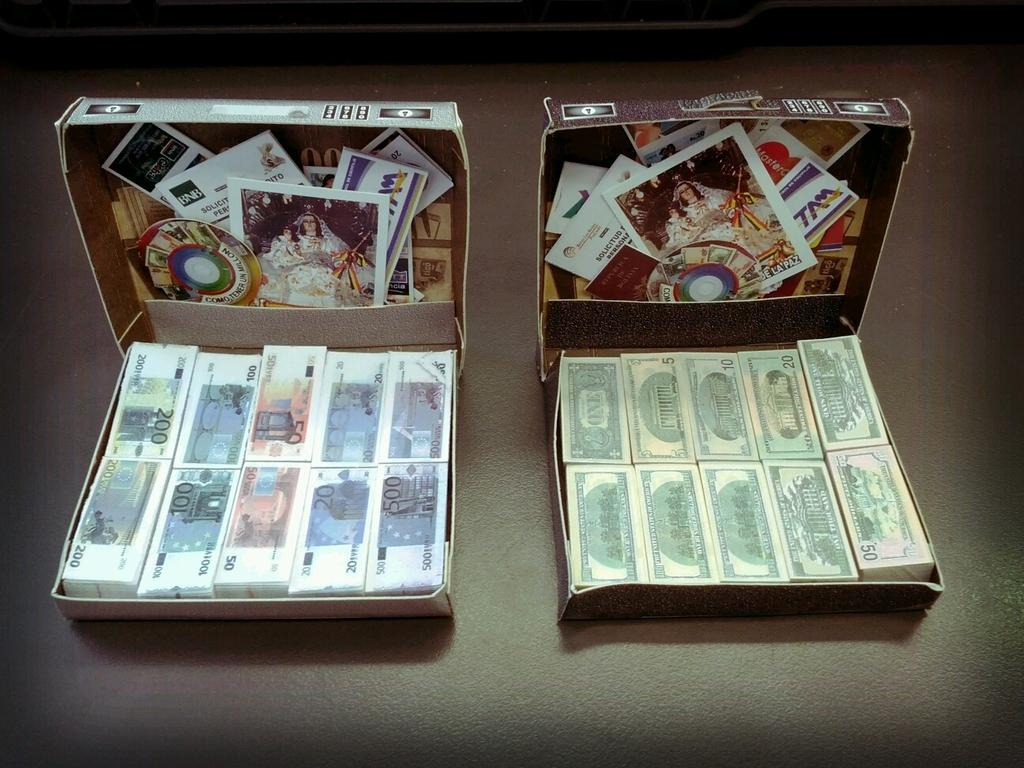Provide a one-sentence caption for the provided image. Two board games showing real and fake cash for $50. 